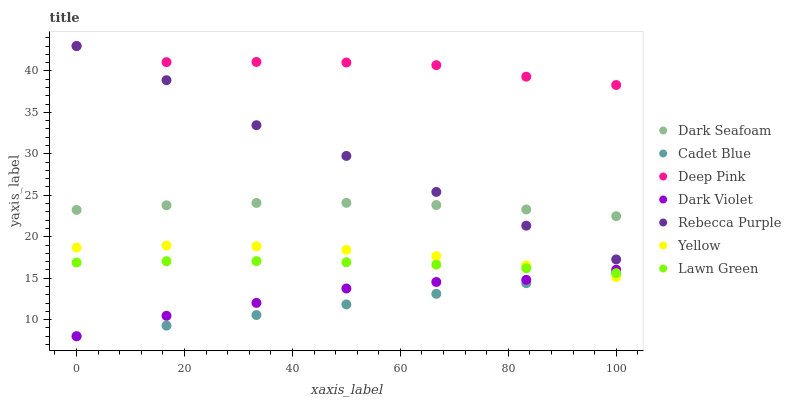Does Cadet Blue have the minimum area under the curve?
Answer yes or no. Yes. Does Deep Pink have the maximum area under the curve?
Answer yes or no. Yes. Does Yellow have the minimum area under the curve?
Answer yes or no. No. Does Yellow have the maximum area under the curve?
Answer yes or no. No. Is Cadet Blue the smoothest?
Answer yes or no. Yes. Is Rebecca Purple the roughest?
Answer yes or no. Yes. Is Yellow the smoothest?
Answer yes or no. No. Is Yellow the roughest?
Answer yes or no. No. Does Cadet Blue have the lowest value?
Answer yes or no. Yes. Does Yellow have the lowest value?
Answer yes or no. No. Does Rebecca Purple have the highest value?
Answer yes or no. Yes. Does Yellow have the highest value?
Answer yes or no. No. Is Lawn Green less than Dark Seafoam?
Answer yes or no. Yes. Is Dark Seafoam greater than Lawn Green?
Answer yes or no. Yes. Does Lawn Green intersect Yellow?
Answer yes or no. Yes. Is Lawn Green less than Yellow?
Answer yes or no. No. Is Lawn Green greater than Yellow?
Answer yes or no. No. Does Lawn Green intersect Dark Seafoam?
Answer yes or no. No. 